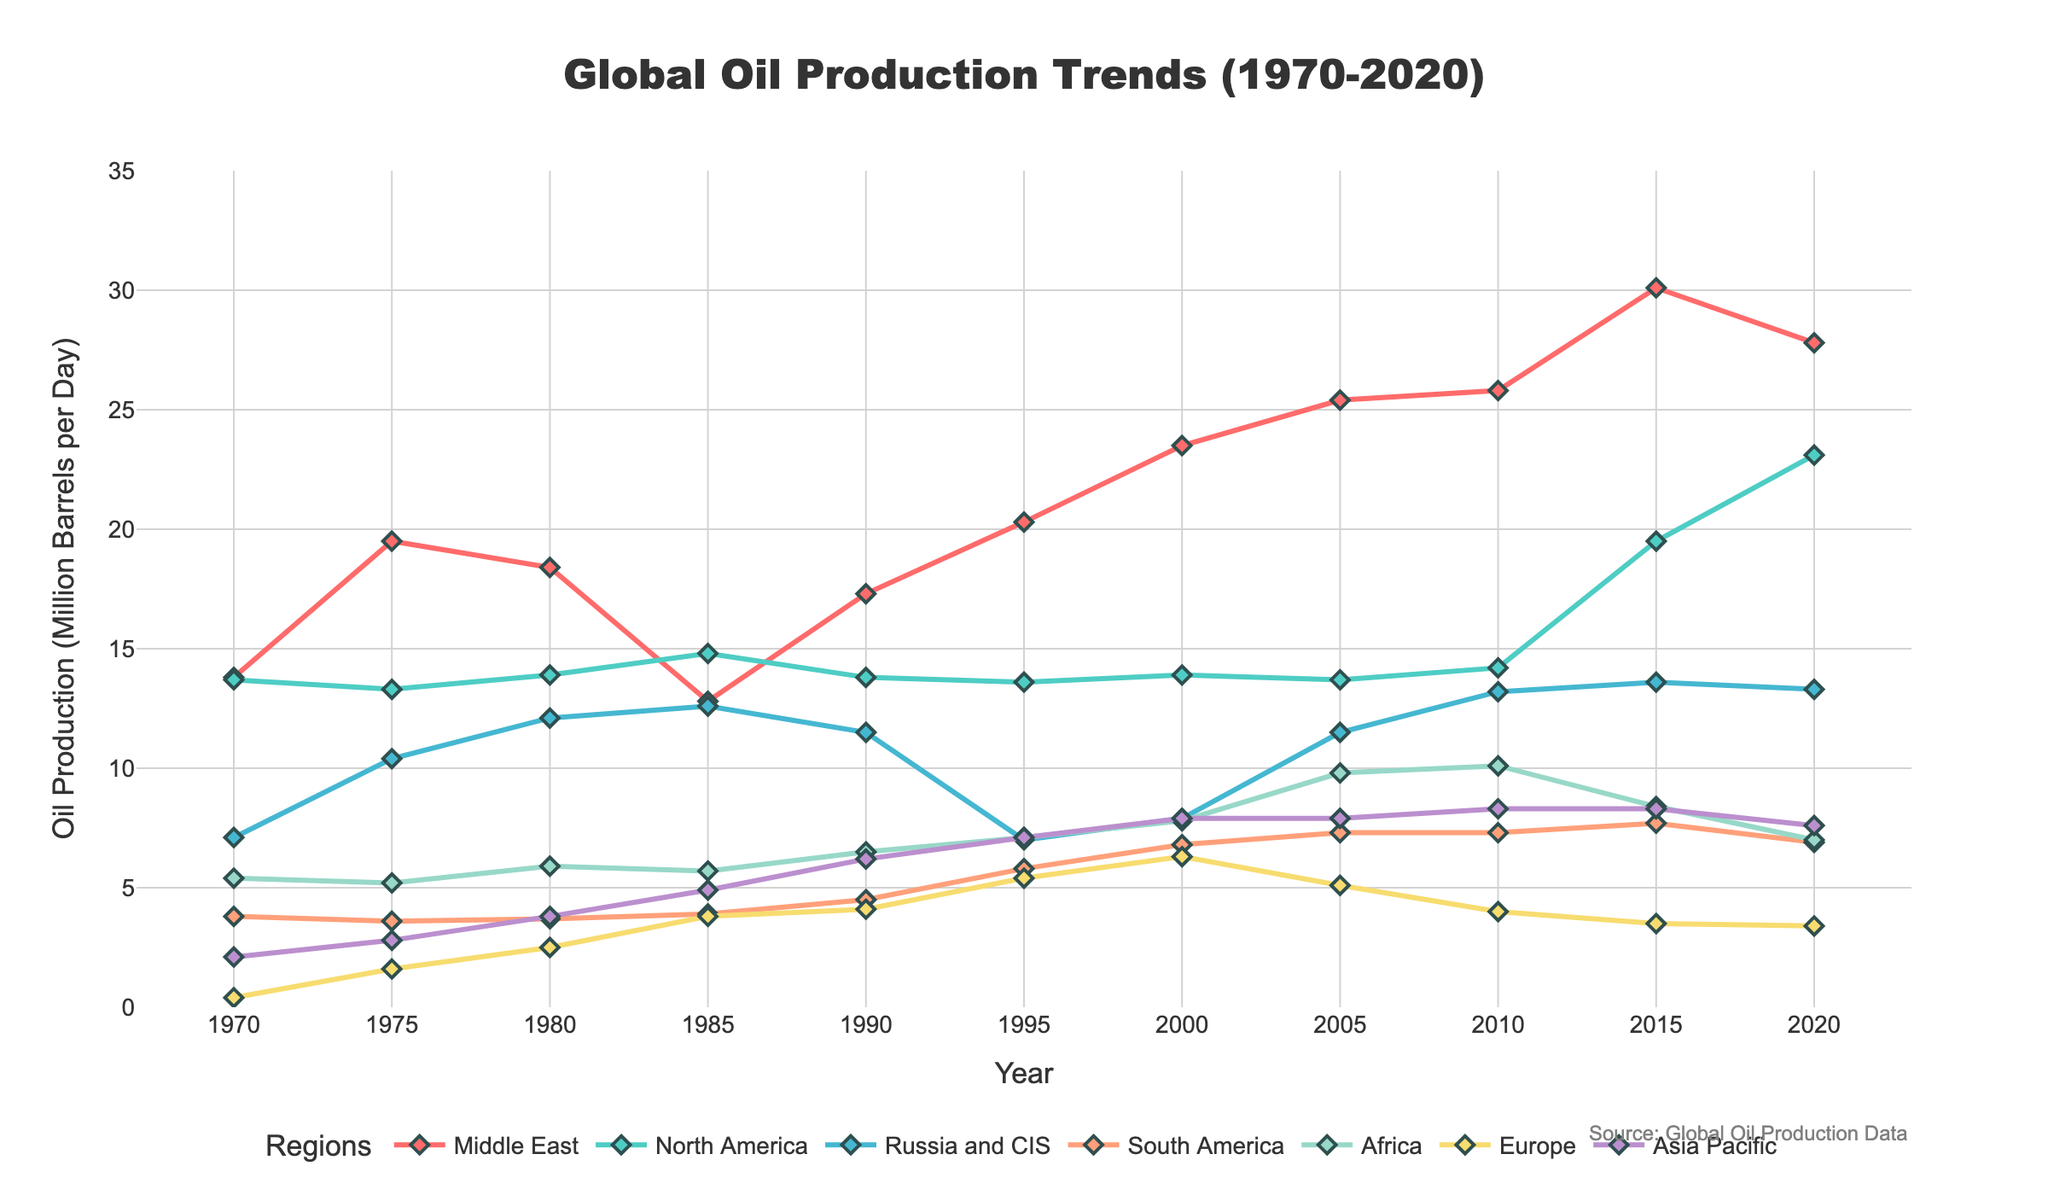What trend can be observed for oil production in the Middle East from 1970 to 2020? To observe the trend, look at the line representing the Middle East. The line starts at a certain level in 1970 and moves significantly higher towards 2020, with some fluctuations in between. Overall, there's an increasing trend.
Answer: Increasing trend Which region had the highest oil production in 2020 and how much was it? Identify the line with the highest point in 2020 on the x-axis. The line for North America is at the top, indicating the highest production. Look at the y-axis value for this point.
Answer: North America, 23.1 million barrels per day How did oil production in Europe change from 1970 to 2020? Examine the line representing Europe starting in 1970 and follow its progression to 2020. In 1970, it was low, peaked around 1995, and then declined steadily towards 2020.
Answer: Increase then decrease What's the difference in oil production between the Middle East and South America in 2000? Locate the points for the Middle East and South America on the x-axis for 2000. Subtract the South America's value from the Middle East's value. Middle East: 23.5, South America: 6.8. The difference is 23.5 - 6.8.
Answer: 16.7 million barrels per day Which regions saw a decrease in oil production from 2015 to 2020? Compare the y-values for 2015 and 2020 for each region. If the value for 2020 is less than 2015, there's a decrease. Middle East, South America, Africa, Europe, Asia Pacific all saw decreases.
Answer: Middle East, South America, Africa, Europe, Asia Pacific What's the average oil production in Asia Pacific from 1990 to 2020? Add the values for the years 1990, 1995, 2000, 2005, 2010, 2015, 2020 and divide by the number of years. (6.2 + 7.1 + 7.9 + 7.9 + 8.3 + 8.3 + 7.6) / 7 = 7.61.
Answer: 7.61 million barrels per day Which regions produced more oil than Africa in 1985? Locate the value for Africa in 1985, then check the values for all other regions in that year. Regions with higher values are Middle East, North America, Russia and CIS, Europe, Asia Pacific.
Answer: Middle East, North America, Russia and CIS, Europe, Asia Pacific How did oil production in Russia and CIS change between 1980 and 1985? Look at the points for Russia and CIS in 1980 and 1985. In 1980, the value is 12.1, and in 1985, it is 12.6. The difference is 12.6 - 12.1, showing an increase.
Answer: Increased by 0.5 million barrels per day What was the highest oil production of North America, and in which year did it occur? Look for the highest point on the North America line and note the corresponding year. The highest point is in 2020 with a value of 23.1.
Answer: 23.1 million barrels per day, in 2020 